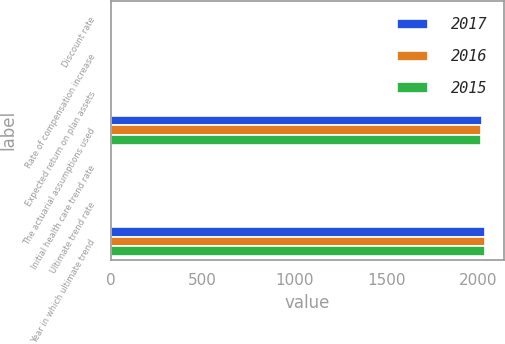Convert chart. <chart><loc_0><loc_0><loc_500><loc_500><stacked_bar_chart><ecel><fcel>Discount rate<fcel>Rate of compensation increase<fcel>Expected return on plan assets<fcel>The actuarial assumptions used<fcel>Initial health care trend rate<fcel>Ultimate trend rate<fcel>Year in which ultimate trend<nl><fcel>2017<fcel>3.3<fcel>4.5<fcel>7.3<fcel>2017<fcel>7.3<fcel>4.5<fcel>2038<nl><fcel>2016<fcel>3.7<fcel>4.6<fcel>7.4<fcel>2016<fcel>7.7<fcel>4.5<fcel>2038<nl><fcel>2015<fcel>4.1<fcel>4.5<fcel>7.5<fcel>2015<fcel>6.7<fcel>4.5<fcel>2038<nl></chart> 